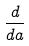<formula> <loc_0><loc_0><loc_500><loc_500>\frac { d } { d a }</formula> 